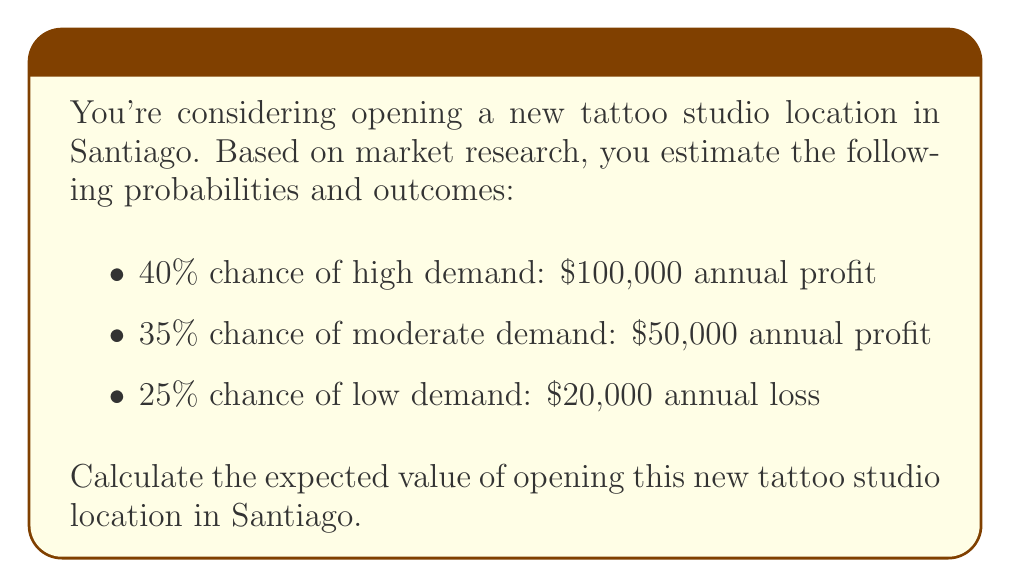Provide a solution to this math problem. To calculate the expected value, we need to multiply each possible outcome by its probability and then sum these products. Let's break it down step-by-step:

1. High demand scenario:
   Probability = 40% = 0.40
   Outcome = $100,000
   Expected value = $100,000 * 0.40 = $40,000

2. Moderate demand scenario:
   Probability = 35% = 0.35
   Outcome = $50,000
   Expected value = $50,000 * 0.35 = $17,500

3. Low demand scenario:
   Probability = 25% = 0.25
   Outcome = -$20,000 (loss)
   Expected value = -$20,000 * 0.25 = -$5,000

Now, we sum these expected values:

$$ EV = 40,000 + 17,500 + (-5,000) = 52,500 $$

Therefore, the expected value of opening the new tattoo studio location in Santiago is $52,500.

This can also be expressed using the formula for expected value:

$$ EV = \sum_{i=1}^{n} p_i \cdot x_i $$

Where $p_i$ is the probability of each outcome and $x_i$ is the value of each outcome.

$$ EV = (0.40 \cdot 100,000) + (0.35 \cdot 50,000) + (0.25 \cdot (-20,000)) = 52,500 $$
Answer: $52,500 